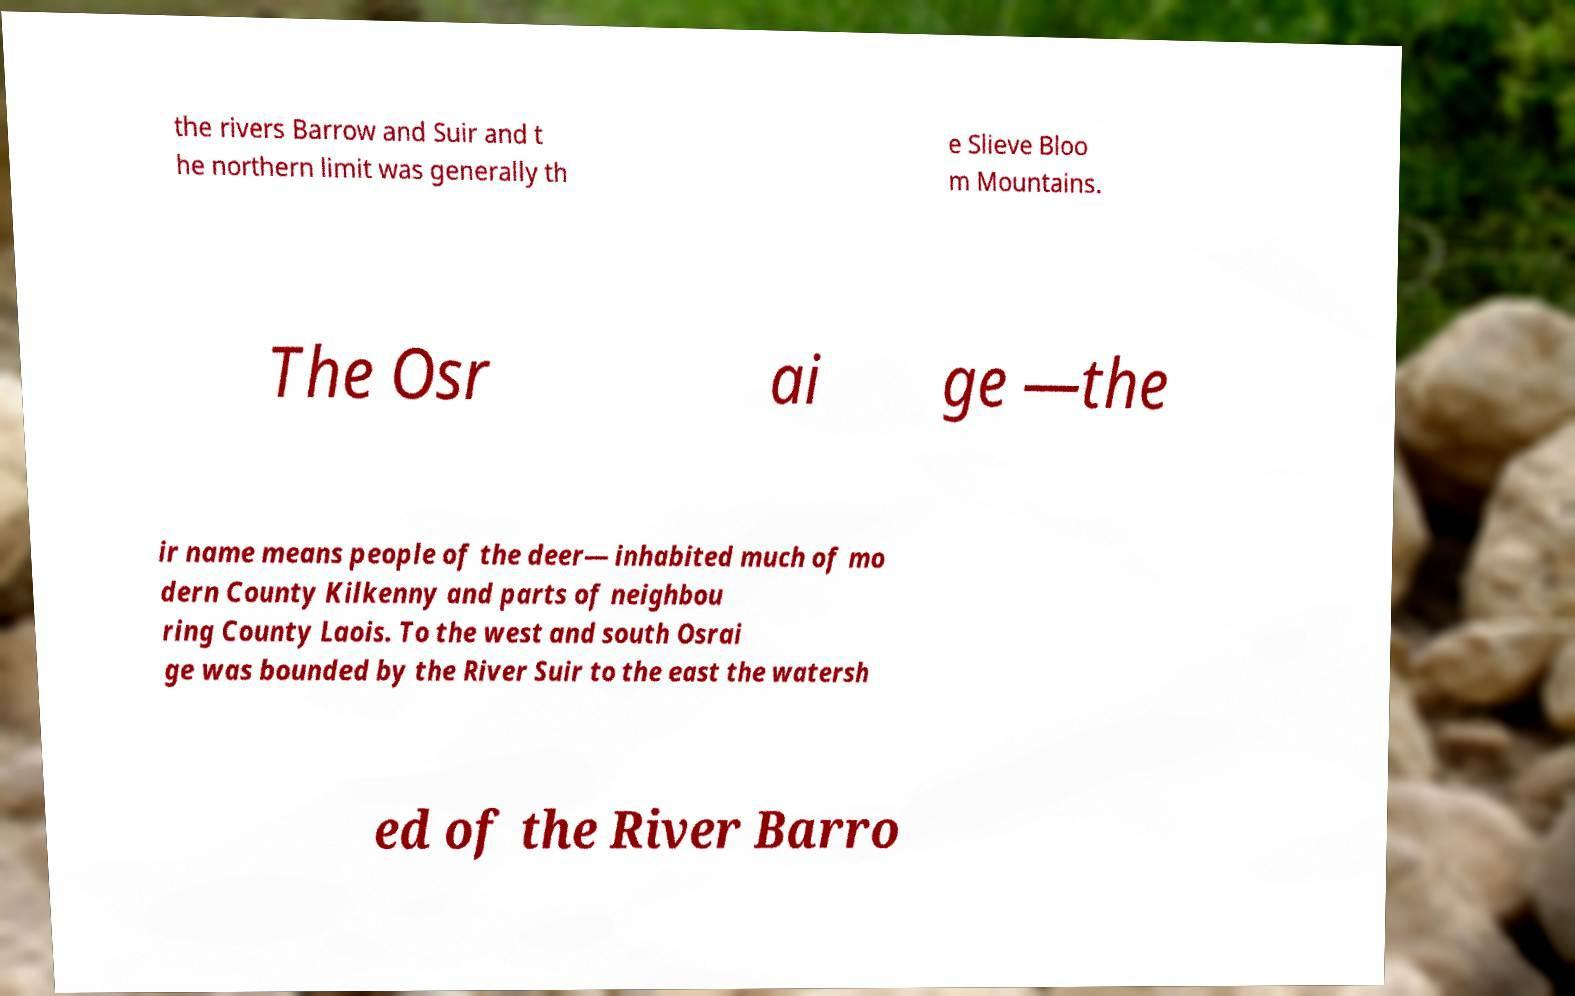For documentation purposes, I need the text within this image transcribed. Could you provide that? the rivers Barrow and Suir and t he northern limit was generally th e Slieve Bloo m Mountains. The Osr ai ge —the ir name means people of the deer— inhabited much of mo dern County Kilkenny and parts of neighbou ring County Laois. To the west and south Osrai ge was bounded by the River Suir to the east the watersh ed of the River Barro 